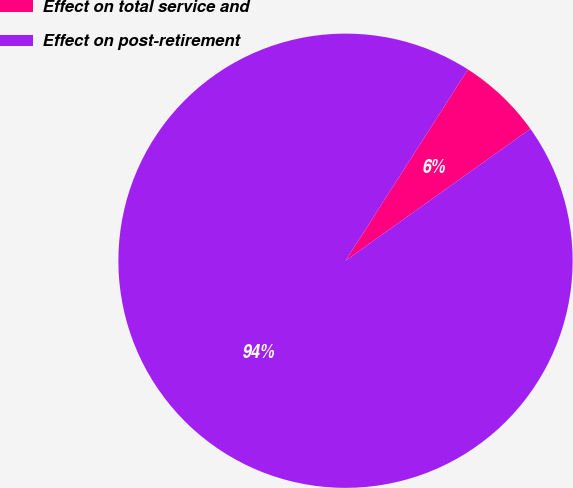<chart> <loc_0><loc_0><loc_500><loc_500><pie_chart><fcel>Effect on total service and<fcel>Effect on post-retirement<nl><fcel>6.08%<fcel>93.92%<nl></chart> 